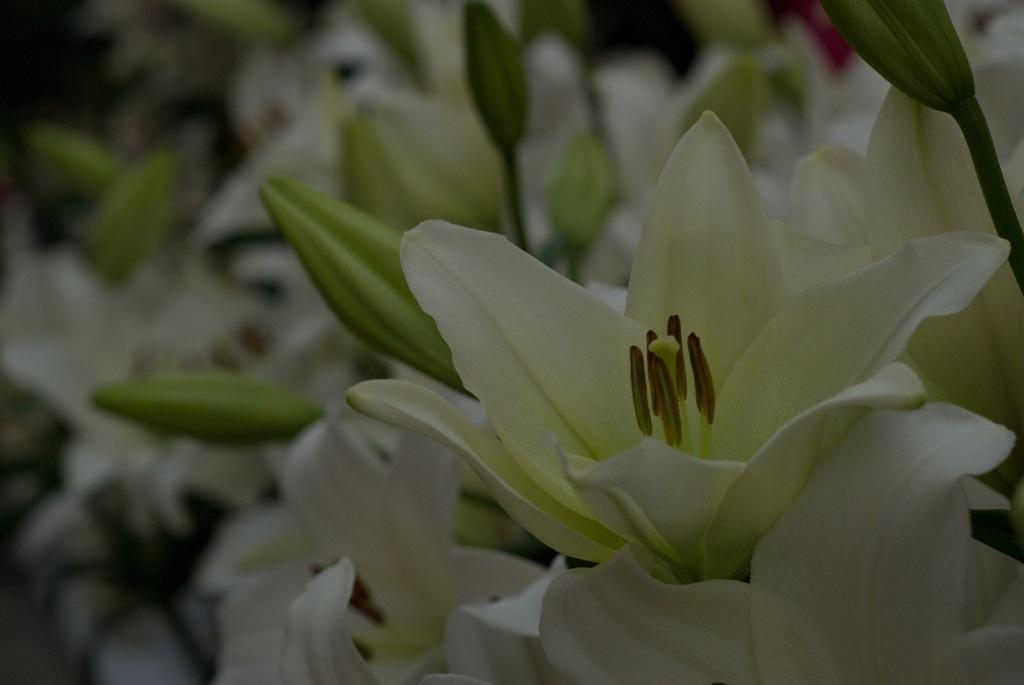What is the location of the image in relation to the city? The image might be taken from outside of the city. What can be seen on the right side of the image? There is a flower on the right side of the image. What is visible in the background of the image? There are buds visible in the background of the image. What color dominates the background of the image? The background has a green color. What date is marked on the calendar in the image? There is no calendar present in the image. What type of clouds can be seen in the image? There are no clouds visible in the image; it features a flower and green background. 